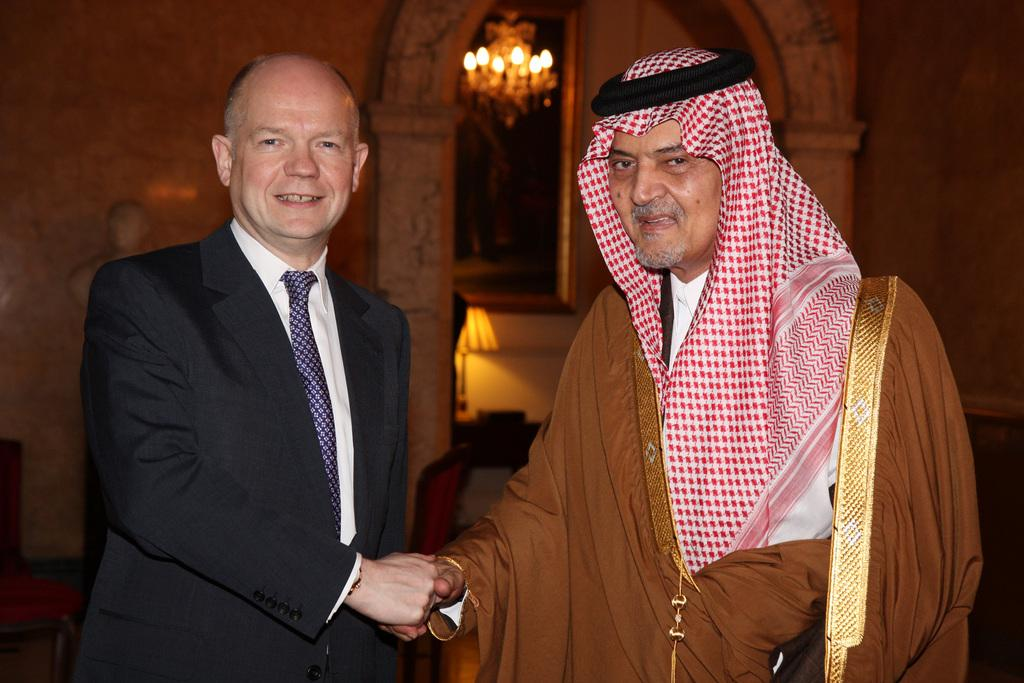What can be seen in the image? There are men standing in the image. Where are the men standing? The men are standing on the floor. What can be seen in the background of the image? There are walls, a wall hanging, and a chandelier in the background of the image. How many parcels are being pushed by the men in the image? There are no parcels or pushing actions depicted in the image. 